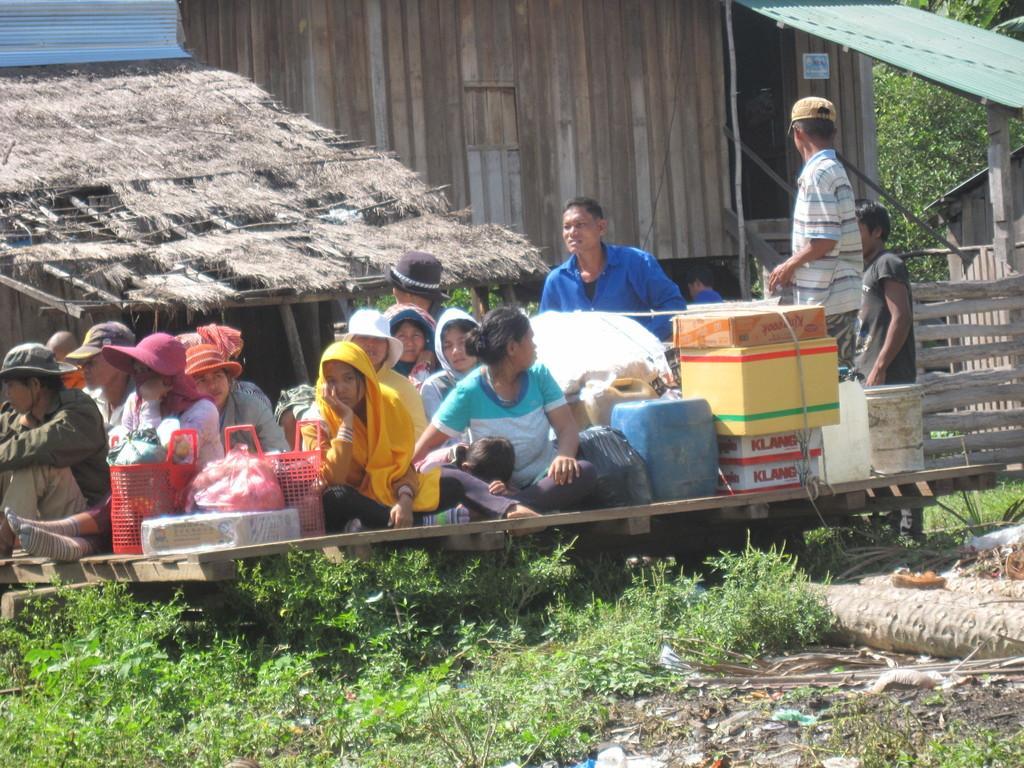Could you give a brief overview of what you see in this image? In the picture we can see a group of people sitting on the wooden plank and besides them we can see some baskets, boxes and behind them we can see a man standing and behind him also we can see some people and near them we can see a wooden house with a shed and poles to it and a railing and beside it we can see trees and beside the house we can see a roof with a dried grass and near the people on the path we can see some some plants. 